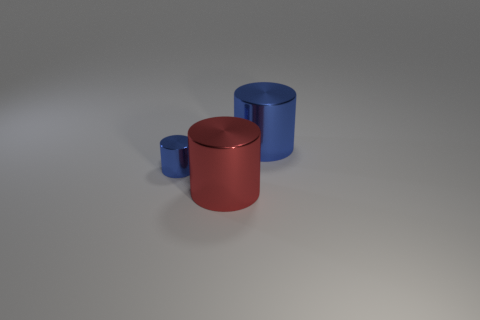Add 3 small metallic things. How many objects exist? 6 Add 2 small yellow balls. How many small yellow balls exist? 2 Subtract 0 purple cubes. How many objects are left? 3 Subtract all tiny gray balls. Subtract all metallic cylinders. How many objects are left? 0 Add 1 red metallic cylinders. How many red metallic cylinders are left? 2 